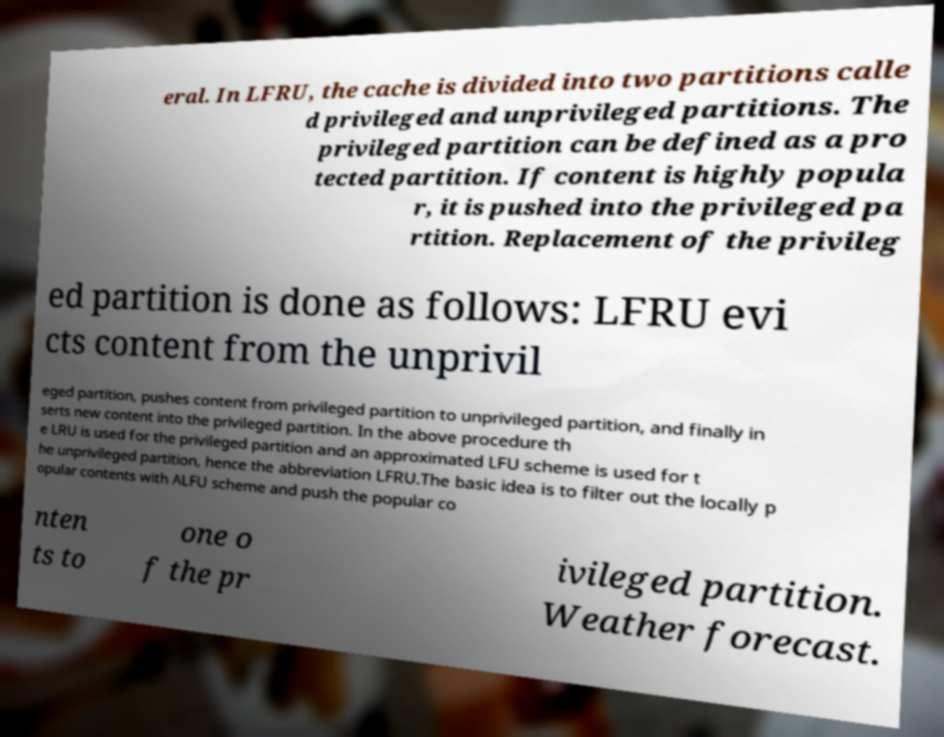Can you accurately transcribe the text from the provided image for me? eral. In LFRU, the cache is divided into two partitions calle d privileged and unprivileged partitions. The privileged partition can be defined as a pro tected partition. If content is highly popula r, it is pushed into the privileged pa rtition. Replacement of the privileg ed partition is done as follows: LFRU evi cts content from the unprivil eged partition, pushes content from privileged partition to unprivileged partition, and finally in serts new content into the privileged partition. In the above procedure th e LRU is used for the privileged partition and an approximated LFU scheme is used for t he unprivileged partition, hence the abbreviation LFRU.The basic idea is to filter out the locally p opular contents with ALFU scheme and push the popular co nten ts to one o f the pr ivileged partition. Weather forecast. 